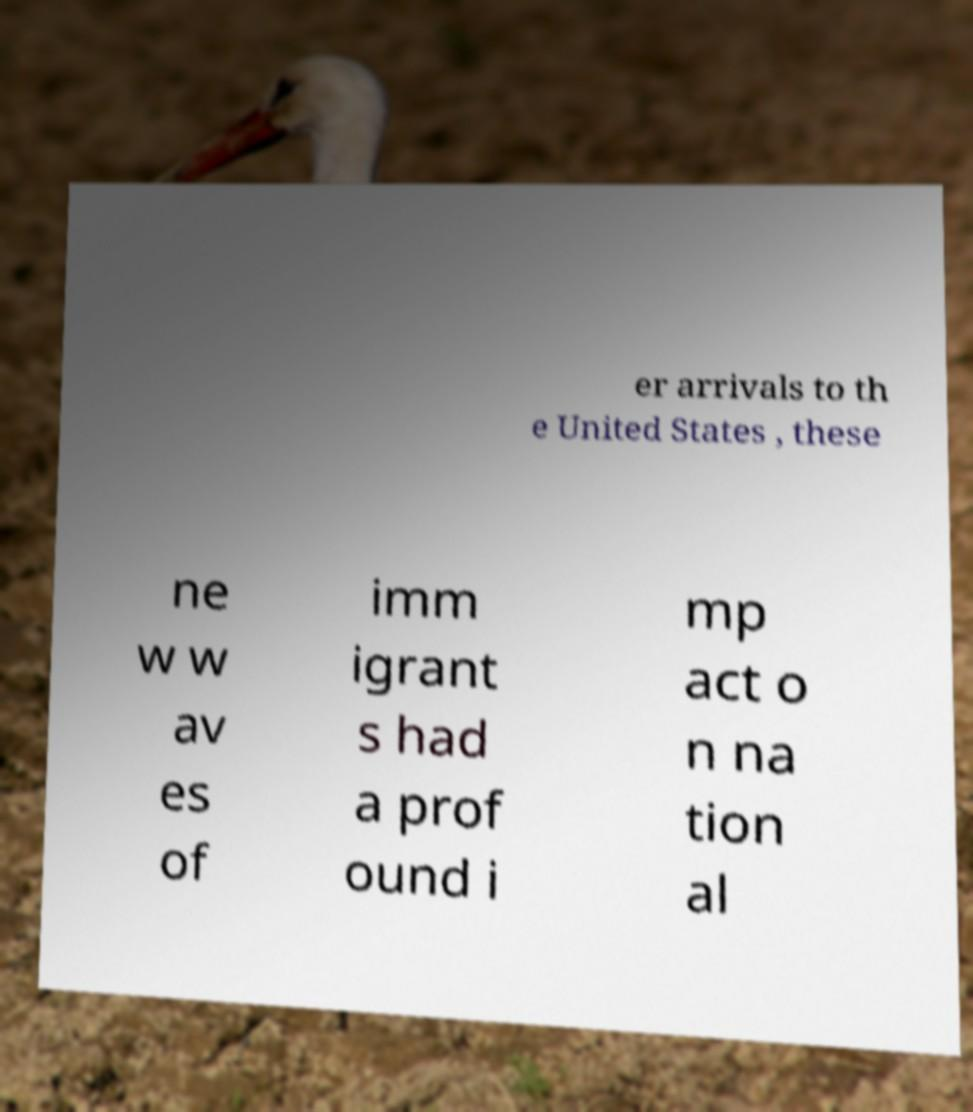Can you accurately transcribe the text from the provided image for me? er arrivals to th e United States , these ne w w av es of imm igrant s had a prof ound i mp act o n na tion al 